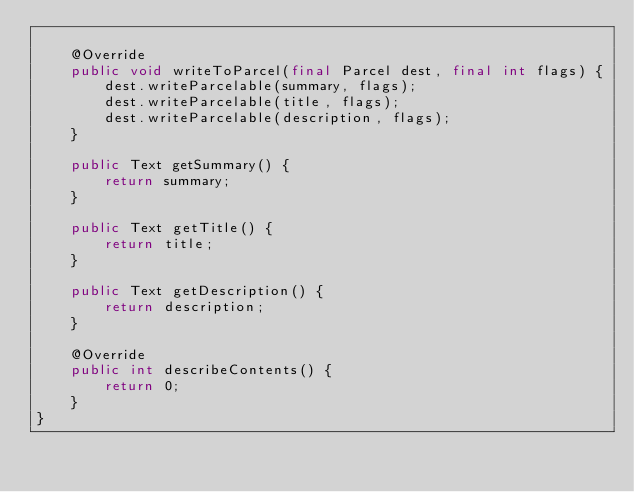<code> <loc_0><loc_0><loc_500><loc_500><_Java_>
    @Override
    public void writeToParcel(final Parcel dest, final int flags) {
        dest.writeParcelable(summary, flags);
        dest.writeParcelable(title, flags);
        dest.writeParcelable(description, flags);
    }

    public Text getSummary() {
        return summary;
    }

    public Text getTitle() {
        return title;
    }

    public Text getDescription() {
        return description;
    }

    @Override
    public int describeContents() {
        return 0;
    }
}</code> 